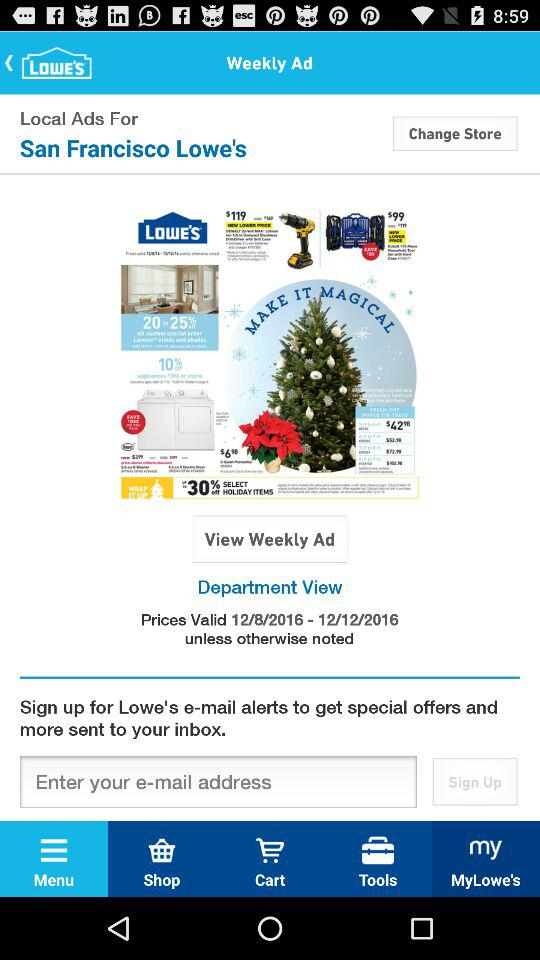Which items are in the cart?
When the provided information is insufficient, respond with <no answer>. <no answer> 